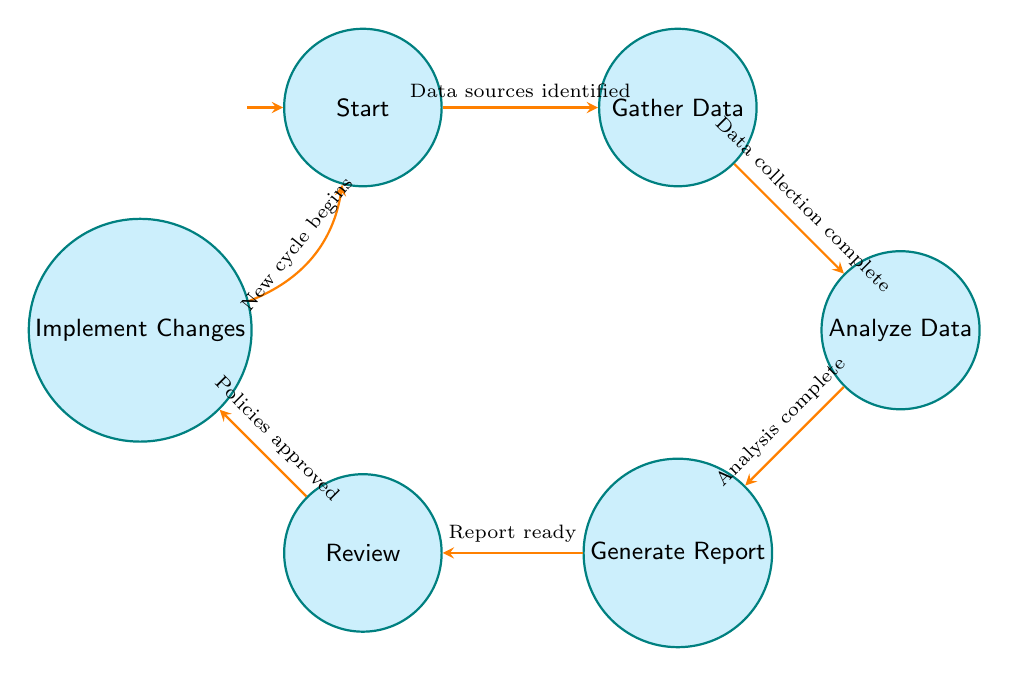What is the initial state of the system? The diagram shows the first node labeled "Start" as the initial state of the tracking system. This clearly indicates the entry point of the process.
Answer: Start How many nodes are in the diagram? The diagram contains a total of six nodes: Start, Gather Data, Analyze Data, Generate Report, Review, and Implement Changes. Counting each one provides the total.
Answer: 6 What follows after the "Gather Data" state? According to the transition indicated in the diagram, after "Gather Data," the next state is "Analyze Data." This is connected by an arrow showing the flow of the process.
Answer: Analyze Data Which state precedes "Implement Changes"? The state leading into "Implement Changes" is "Review," as indicated in the diagram by the directed edge pointing to "Implement Changes."
Answer: Review What action is taken after the "Report is ready"? When the report is ready, the next action is to proceed to the "Review" state where the findings are discussed. This is illustrated by the arrow leading from "Generate Report" to "Review."
Answer: Review What condition triggers the transition from "Analyze Data" to "Generate Report"? The transition from "Analyze Data" to "Generate Report" occurs when the condition of "Analysis complete" is met, as noted in the diagram. This is a necessary step for the process to proceed.
Answer: Analysis complete How many transitions are there in the diagram? The diagram illustrates a total of six transitions connecting the different states, signifying the flow from one state to another. Each transition corresponds to a specific condition.
Answer: 6 What action is included in the "Implement Changes" state? The actions listed in the "Implement Changes" state include "Install energy-efficient equipment," indicating a focus on enhancing sustainability in port operations.
Answer: Install energy-efficient equipment What is the condition for transitioning from "Review" to "Implement Changes"? The condition necessary to transition from "Review" to "Implement Changes" is when "Policies approved" is achieved, enabling the implementation of new policies.
Answer: Policies approved 